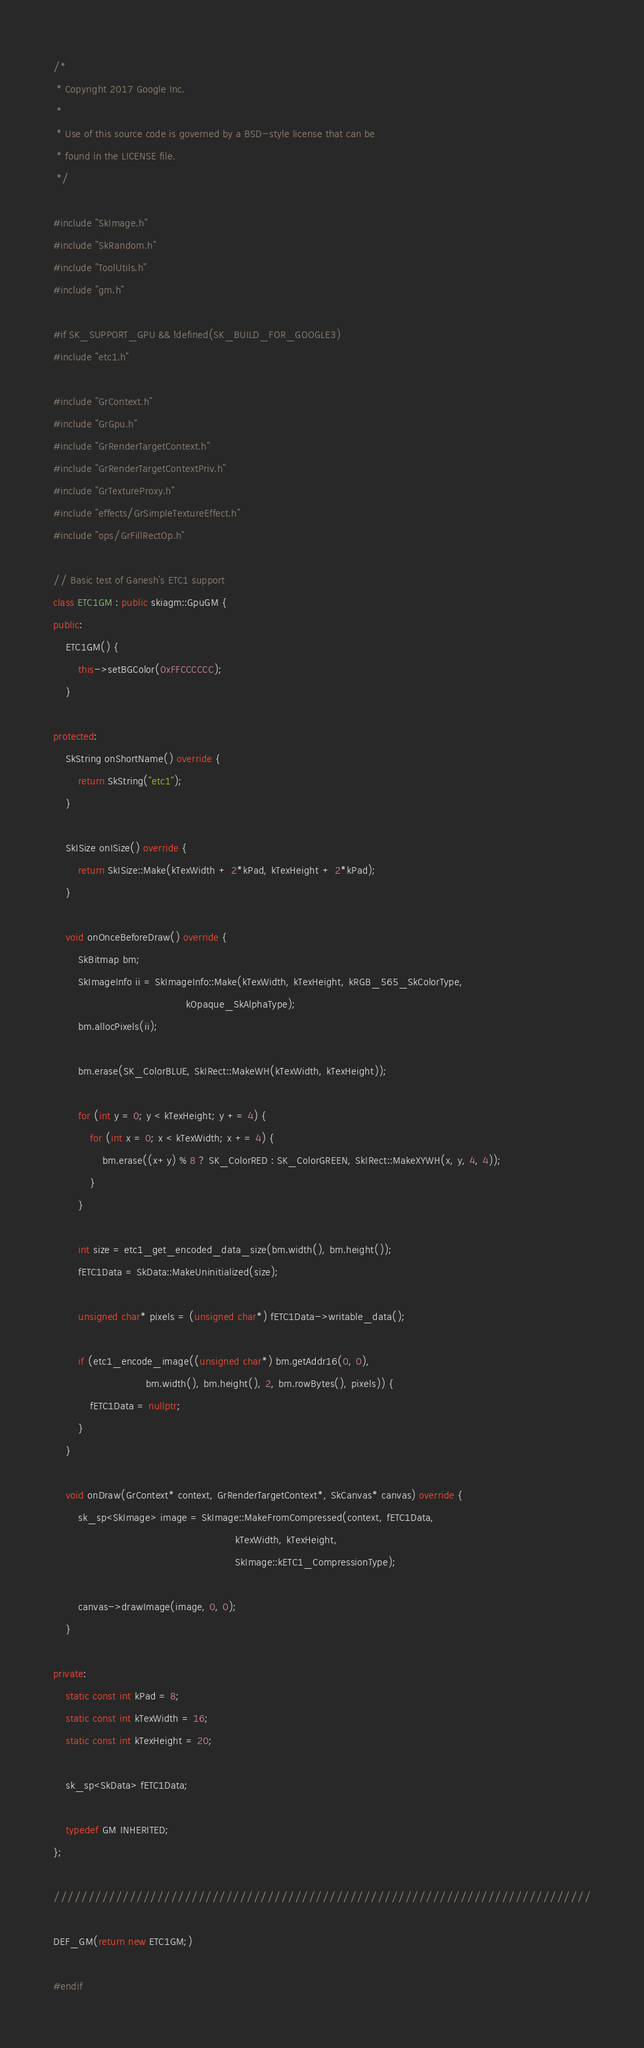Convert code to text. <code><loc_0><loc_0><loc_500><loc_500><_C++_>/*
 * Copyright 2017 Google Inc.
 *
 * Use of this source code is governed by a BSD-style license that can be
 * found in the LICENSE file.
 */

#include "SkImage.h"
#include "SkRandom.h"
#include "ToolUtils.h"
#include "gm.h"

#if SK_SUPPORT_GPU && !defined(SK_BUILD_FOR_GOOGLE3)
#include "etc1.h"

#include "GrContext.h"
#include "GrGpu.h"
#include "GrRenderTargetContext.h"
#include "GrRenderTargetContextPriv.h"
#include "GrTextureProxy.h"
#include "effects/GrSimpleTextureEffect.h"
#include "ops/GrFillRectOp.h"

// Basic test of Ganesh's ETC1 support
class ETC1GM : public skiagm::GpuGM {
public:
    ETC1GM() {
        this->setBGColor(0xFFCCCCCC);
    }

protected:
    SkString onShortName() override {
        return SkString("etc1");
    }

    SkISize onISize() override {
        return SkISize::Make(kTexWidth + 2*kPad, kTexHeight + 2*kPad);
    }

    void onOnceBeforeDraw() override {
        SkBitmap bm;
        SkImageInfo ii = SkImageInfo::Make(kTexWidth, kTexHeight, kRGB_565_SkColorType,
                                           kOpaque_SkAlphaType);
        bm.allocPixels(ii);

        bm.erase(SK_ColorBLUE, SkIRect::MakeWH(kTexWidth, kTexHeight));

        for (int y = 0; y < kTexHeight; y += 4) {
            for (int x = 0; x < kTexWidth; x += 4) {
                bm.erase((x+y) % 8 ? SK_ColorRED : SK_ColorGREEN, SkIRect::MakeXYWH(x, y, 4, 4));
            }
        }

        int size = etc1_get_encoded_data_size(bm.width(), bm.height());
        fETC1Data = SkData::MakeUninitialized(size);

        unsigned char* pixels = (unsigned char*) fETC1Data->writable_data();

        if (etc1_encode_image((unsigned char*) bm.getAddr16(0, 0),
                              bm.width(), bm.height(), 2, bm.rowBytes(), pixels)) {
            fETC1Data = nullptr;
        }
    }

    void onDraw(GrContext* context, GrRenderTargetContext*, SkCanvas* canvas) override {
        sk_sp<SkImage> image = SkImage::MakeFromCompressed(context, fETC1Data,
                                                           kTexWidth, kTexHeight,
                                                           SkImage::kETC1_CompressionType);

        canvas->drawImage(image, 0, 0);
    }

private:
    static const int kPad = 8;
    static const int kTexWidth = 16;
    static const int kTexHeight = 20;

    sk_sp<SkData> fETC1Data;

    typedef GM INHERITED;
};

//////////////////////////////////////////////////////////////////////////////

DEF_GM(return new ETC1GM;)

#endif
</code> 